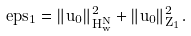<formula> <loc_0><loc_0><loc_500><loc_500>\ e p s _ { 1 } = \| u _ { 0 } \| _ { H ^ { N } _ { w } } ^ { 2 } + \| u _ { 0 } \| _ { Z _ { 1 } } ^ { 2 } .</formula> 